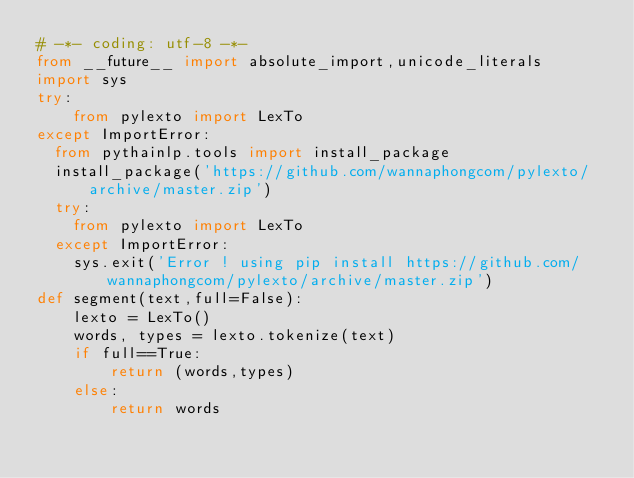<code> <loc_0><loc_0><loc_500><loc_500><_Python_># -*- coding: utf-8 -*-
from __future__ import absolute_import,unicode_literals
import sys
try:
    from pylexto import LexTo
except ImportError:
	from pythainlp.tools import install_package
	install_package('https://github.com/wannaphongcom/pylexto/archive/master.zip')
	try:
		from pylexto import LexTo
	except ImportError:
		sys.exit('Error ! using pip install https://github.com/wannaphongcom/pylexto/archive/master.zip')
def segment(text,full=False):
    lexto = LexTo()
    words, types = lexto.tokenize(text)
    if full==True:
        return (words,types)
    else:
        return words
</code> 